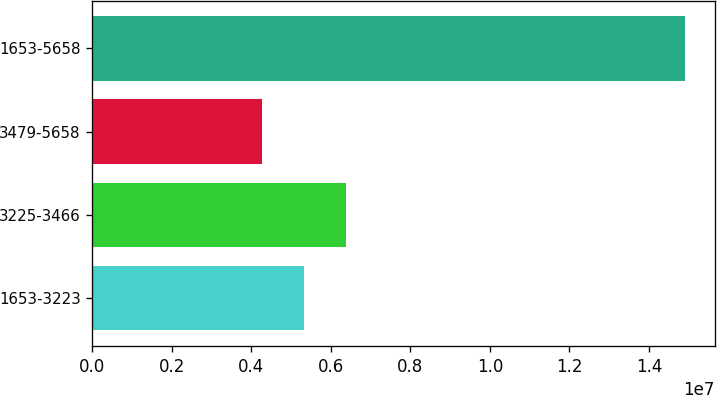Convert chart. <chart><loc_0><loc_0><loc_500><loc_500><bar_chart><fcel>1653-3223<fcel>3225-3466<fcel>3479-5658<fcel>1653-5658<nl><fcel>5.32547e+06<fcel>6.39037e+06<fcel>4.26058e+06<fcel>1.49095e+07<nl></chart> 